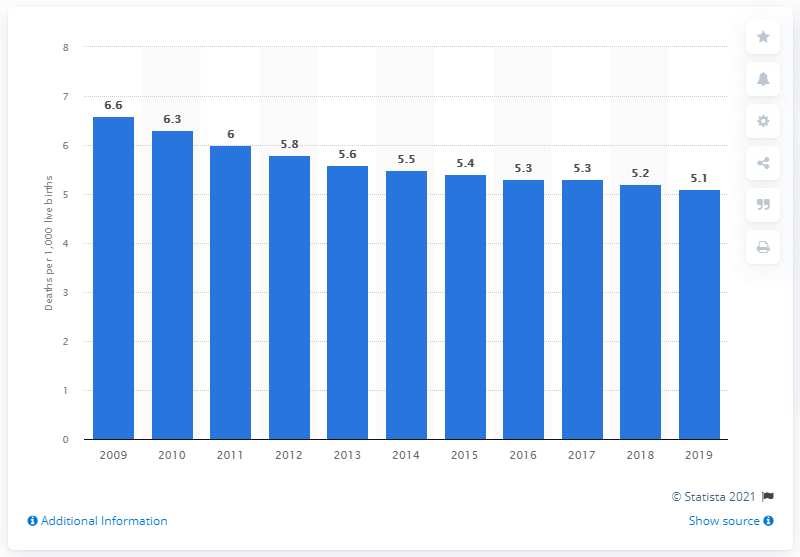Outline some significant characteristics in this image. In 2019, the infant mortality rate in Bosnia and Herzegovina was 5.1 deaths per 1,000 live births. 